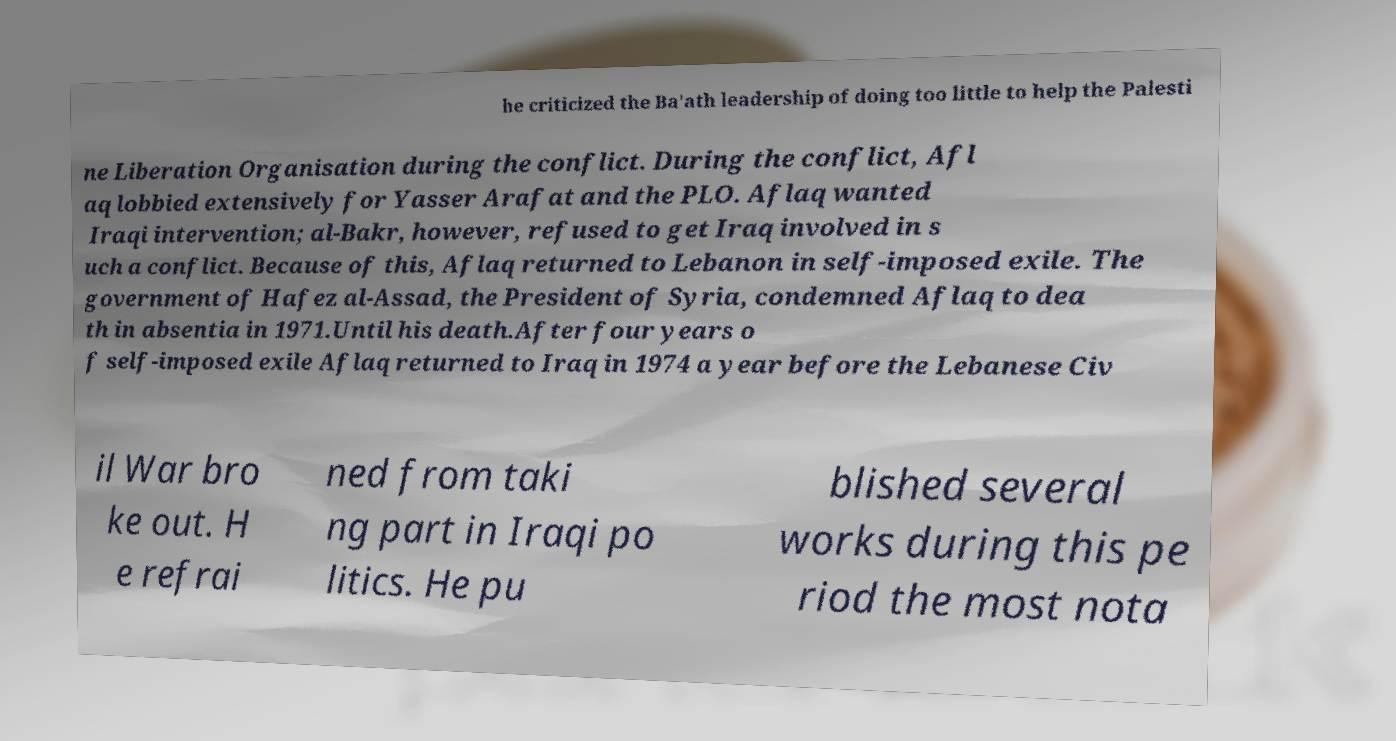There's text embedded in this image that I need extracted. Can you transcribe it verbatim? he criticized the Ba'ath leadership of doing too little to help the Palesti ne Liberation Organisation during the conflict. During the conflict, Afl aq lobbied extensively for Yasser Arafat and the PLO. Aflaq wanted Iraqi intervention; al-Bakr, however, refused to get Iraq involved in s uch a conflict. Because of this, Aflaq returned to Lebanon in self-imposed exile. The government of Hafez al-Assad, the President of Syria, condemned Aflaq to dea th in absentia in 1971.Until his death.After four years o f self-imposed exile Aflaq returned to Iraq in 1974 a year before the Lebanese Civ il War bro ke out. H e refrai ned from taki ng part in Iraqi po litics. He pu blished several works during this pe riod the most nota 